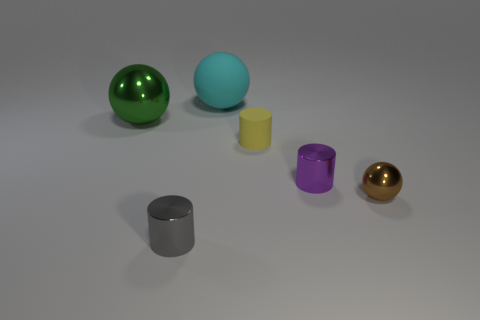There is a metallic ball on the left side of the large matte object; is it the same size as the metal cylinder that is right of the tiny yellow cylinder?
Keep it short and to the point. No. What is the material of the big ball right of the tiny cylinder that is in front of the brown sphere?
Ensure brevity in your answer.  Rubber. Is the number of small purple metallic things on the right side of the purple metallic cylinder less than the number of small metal balls?
Provide a succinct answer. Yes. There is a green object that is the same material as the purple cylinder; what shape is it?
Make the answer very short. Sphere. What number of other things are there of the same shape as the cyan matte thing?
Your answer should be compact. 2. What number of cyan objects are either cylinders or rubber cylinders?
Give a very brief answer. 0. Do the brown metal object and the big green thing have the same shape?
Your response must be concise. Yes. There is a metallic sphere that is left of the brown shiny sphere; is there a tiny brown sphere that is to the left of it?
Make the answer very short. No. Are there an equal number of tiny shiny things in front of the small yellow cylinder and large cyan things?
Your answer should be compact. No. What number of other things are the same size as the cyan rubber thing?
Make the answer very short. 1. 